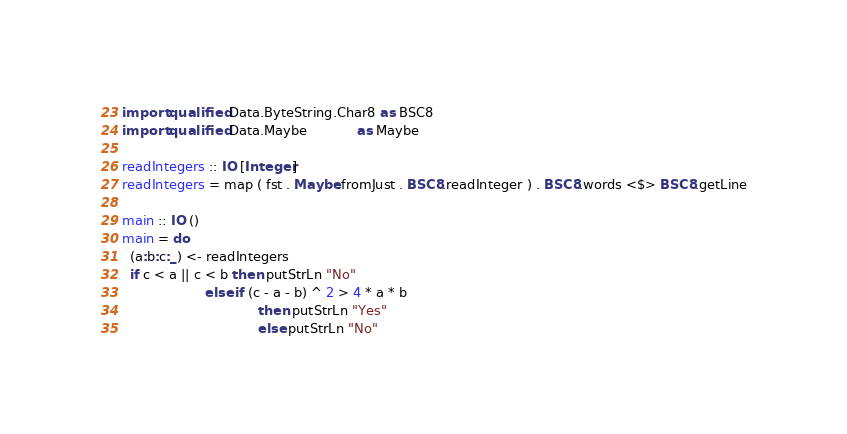<code> <loc_0><loc_0><loc_500><loc_500><_Haskell_>import qualified Data.ByteString.Char8 as BSC8
import qualified Data.Maybe            as Maybe

readIntegers :: IO [Integer]
readIntegers = map ( fst . Maybe.fromJust . BSC8.readInteger ) . BSC8.words <$> BSC8.getLine

main :: IO ()
main = do
  (a:b:c:_) <- readIntegers
  if c < a || c < b then putStrLn "No" 
                    else if (c - a - b) ^ 2 > 4 * a * b
                                 then putStrLn "Yes"
                                 else putStrLn "No"
</code> 